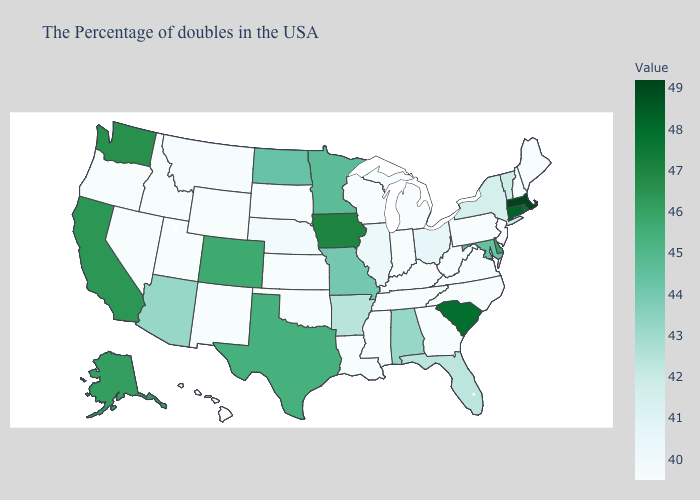Which states have the highest value in the USA?
Be succinct. Massachusetts. Does Michigan have the highest value in the MidWest?
Answer briefly. No. Among the states that border North Carolina , which have the lowest value?
Keep it brief. Virginia, Georgia, Tennessee. Does Massachusetts have the highest value in the USA?
Short answer required. Yes. Among the states that border West Virginia , which have the lowest value?
Quick response, please. Pennsylvania, Virginia, Kentucky. 